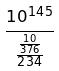<formula> <loc_0><loc_0><loc_500><loc_500>\frac { 1 0 ^ { 1 4 5 } } { \frac { \frac { 1 0 } { 3 7 6 } } { 2 3 4 } }</formula> 